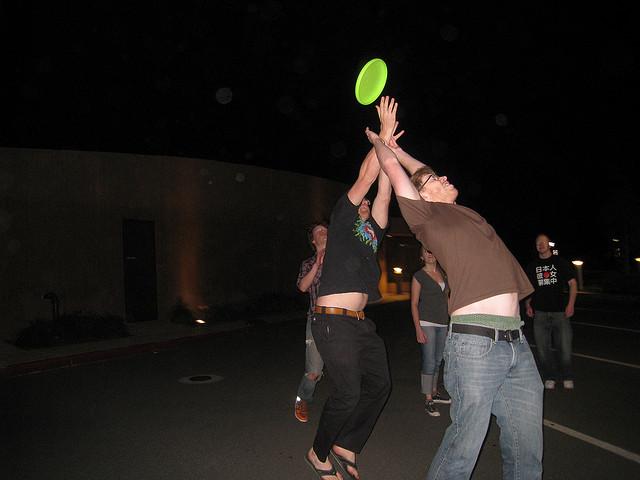What is the person doing?
Concise answer only. Frisbee. What sport is the man playing?
Give a very brief answer. Frisbee. What is showing when the men raise their arms?
Keep it brief. Stomach. What kind of shoes is the man in black wearing?
Concise answer only. Sandals. What is the person holding over their head?
Short answer required. Frisbee. Of the two men, who is reaching higher - the one in the front or in the back?
Short answer required. Back. Where is he?
Answer briefly. Parking lot. 